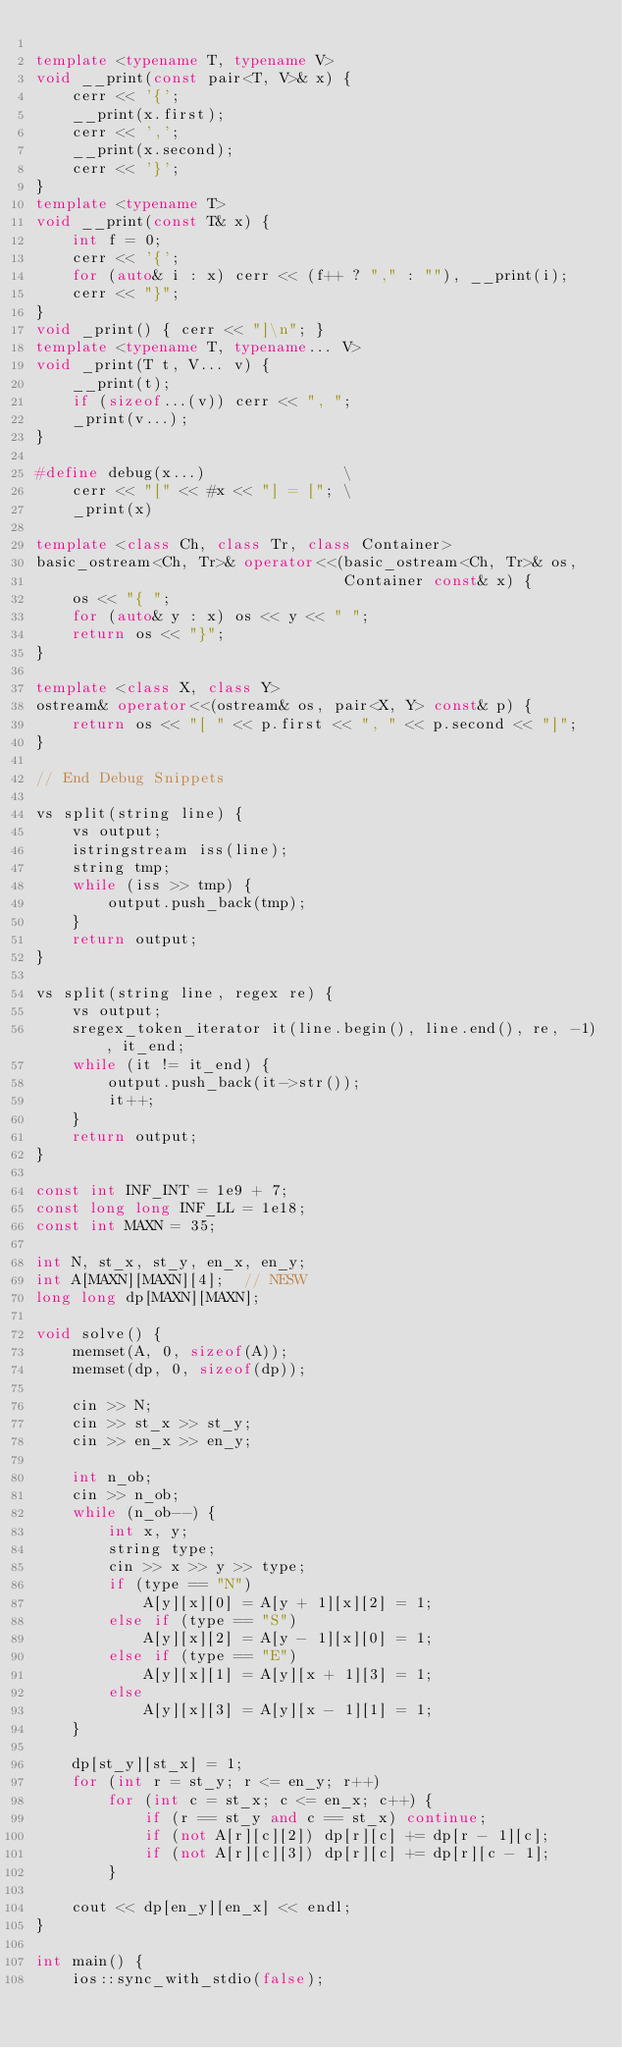Convert code to text. <code><loc_0><loc_0><loc_500><loc_500><_C++_>
template <typename T, typename V>
void __print(const pair<T, V>& x) {
    cerr << '{';
    __print(x.first);
    cerr << ',';
    __print(x.second);
    cerr << '}';
}
template <typename T>
void __print(const T& x) {
    int f = 0;
    cerr << '{';
    for (auto& i : x) cerr << (f++ ? "," : ""), __print(i);
    cerr << "}";
}
void _print() { cerr << "]\n"; }
template <typename T, typename... V>
void _print(T t, V... v) {
    __print(t);
    if (sizeof...(v)) cerr << ", ";
    _print(v...);
}

#define debug(x...)               \
    cerr << "[" << #x << "] = ["; \
    _print(x)

template <class Ch, class Tr, class Container>
basic_ostream<Ch, Tr>& operator<<(basic_ostream<Ch, Tr>& os,
                                  Container const& x) {
    os << "{ ";
    for (auto& y : x) os << y << " ";
    return os << "}";
}

template <class X, class Y>
ostream& operator<<(ostream& os, pair<X, Y> const& p) {
    return os << "[ " << p.first << ", " << p.second << "]";
}

// End Debug Snippets

vs split(string line) {
    vs output;
    istringstream iss(line);
    string tmp;
    while (iss >> tmp) {
        output.push_back(tmp);
    }
    return output;
}

vs split(string line, regex re) {
    vs output;
    sregex_token_iterator it(line.begin(), line.end(), re, -1), it_end;
    while (it != it_end) {
        output.push_back(it->str());
        it++;
    }
    return output;
}

const int INF_INT = 1e9 + 7;
const long long INF_LL = 1e18;
const int MAXN = 35;

int N, st_x, st_y, en_x, en_y;
int A[MAXN][MAXN][4];  // NESW
long long dp[MAXN][MAXN];

void solve() {
    memset(A, 0, sizeof(A));
    memset(dp, 0, sizeof(dp));

    cin >> N;
    cin >> st_x >> st_y;
    cin >> en_x >> en_y;

    int n_ob;
    cin >> n_ob;
    while (n_ob--) {
        int x, y;
        string type;
        cin >> x >> y >> type;
        if (type == "N")
            A[y][x][0] = A[y + 1][x][2] = 1;
        else if (type == "S")
            A[y][x][2] = A[y - 1][x][0] = 1;
        else if (type == "E")
            A[y][x][1] = A[y][x + 1][3] = 1;
        else
            A[y][x][3] = A[y][x - 1][1] = 1;
    }

    dp[st_y][st_x] = 1;
    for (int r = st_y; r <= en_y; r++)
        for (int c = st_x; c <= en_x; c++) {
            if (r == st_y and c == st_x) continue;
            if (not A[r][c][2]) dp[r][c] += dp[r - 1][c];
            if (not A[r][c][3]) dp[r][c] += dp[r][c - 1];
        }

    cout << dp[en_y][en_x] << endl;
}

int main() {
    ios::sync_with_stdio(false);</code> 